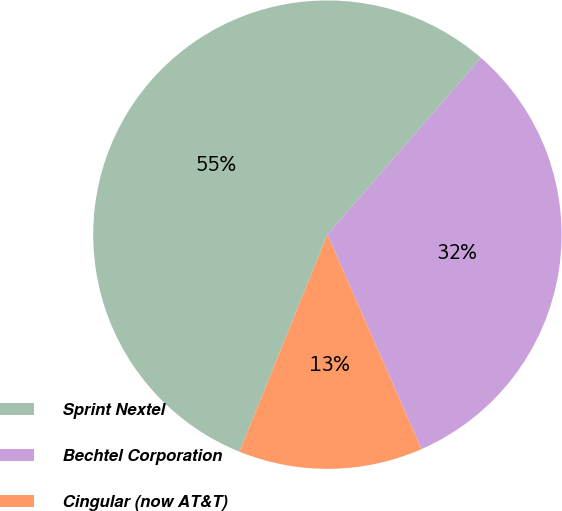Convert chart. <chart><loc_0><loc_0><loc_500><loc_500><pie_chart><fcel>Sprint Nextel<fcel>Bechtel Corporation<fcel>Cingular (now AT&T)<nl><fcel>55.25%<fcel>32.04%<fcel>12.71%<nl></chart> 